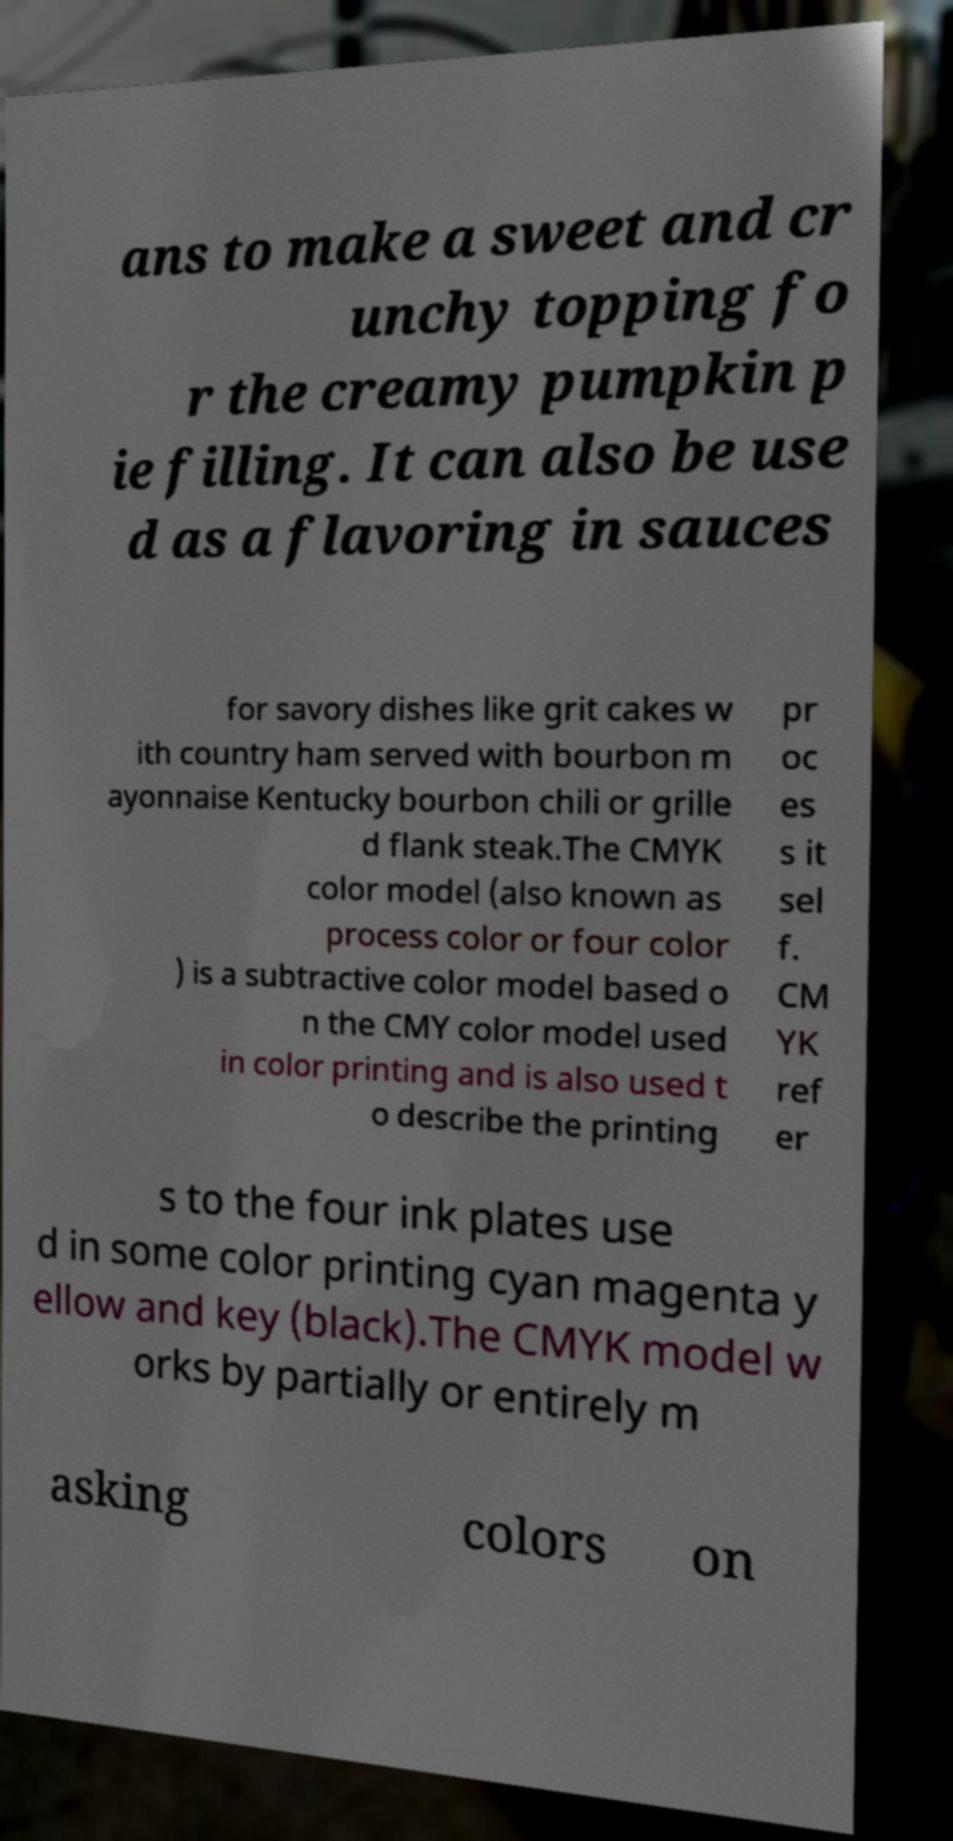Please read and relay the text visible in this image. What does it say? ans to make a sweet and cr unchy topping fo r the creamy pumpkin p ie filling. It can also be use d as a flavoring in sauces for savory dishes like grit cakes w ith country ham served with bourbon m ayonnaise Kentucky bourbon chili or grille d flank steak.The CMYK color model (also known as process color or four color ) is a subtractive color model based o n the CMY color model used in color printing and is also used t o describe the printing pr oc es s it sel f. CM YK ref er s to the four ink plates use d in some color printing cyan magenta y ellow and key (black).The CMYK model w orks by partially or entirely m asking colors on 